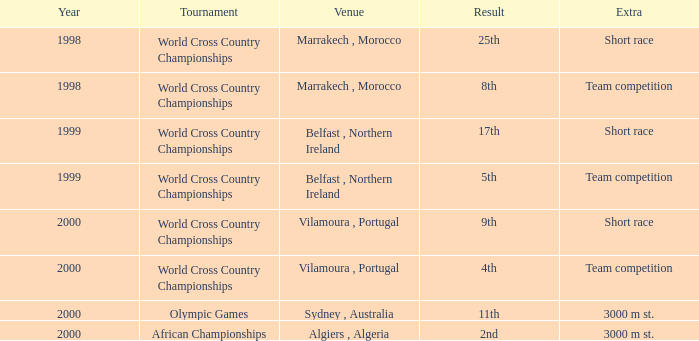Could you parse the entire table as a dict? {'header': ['Year', 'Tournament', 'Venue', 'Result', 'Extra'], 'rows': [['1998', 'World Cross Country Championships', 'Marrakech , Morocco', '25th', 'Short race'], ['1998', 'World Cross Country Championships', 'Marrakech , Morocco', '8th', 'Team competition'], ['1999', 'World Cross Country Championships', 'Belfast , Northern Ireland', '17th', 'Short race'], ['1999', 'World Cross Country Championships', 'Belfast , Northern Ireland', '5th', 'Team competition'], ['2000', 'World Cross Country Championships', 'Vilamoura , Portugal', '9th', 'Short race'], ['2000', 'World Cross Country Championships', 'Vilamoura , Portugal', '4th', 'Team competition'], ['2000', 'Olympic Games', 'Sydney , Australia', '11th', '3000 m st.'], ['2000', 'African Championships', 'Algiers , Algeria', '2nd', '3000 m st.']]} Tell me the venue for extra of short race and year less than 1999 Marrakech , Morocco. 